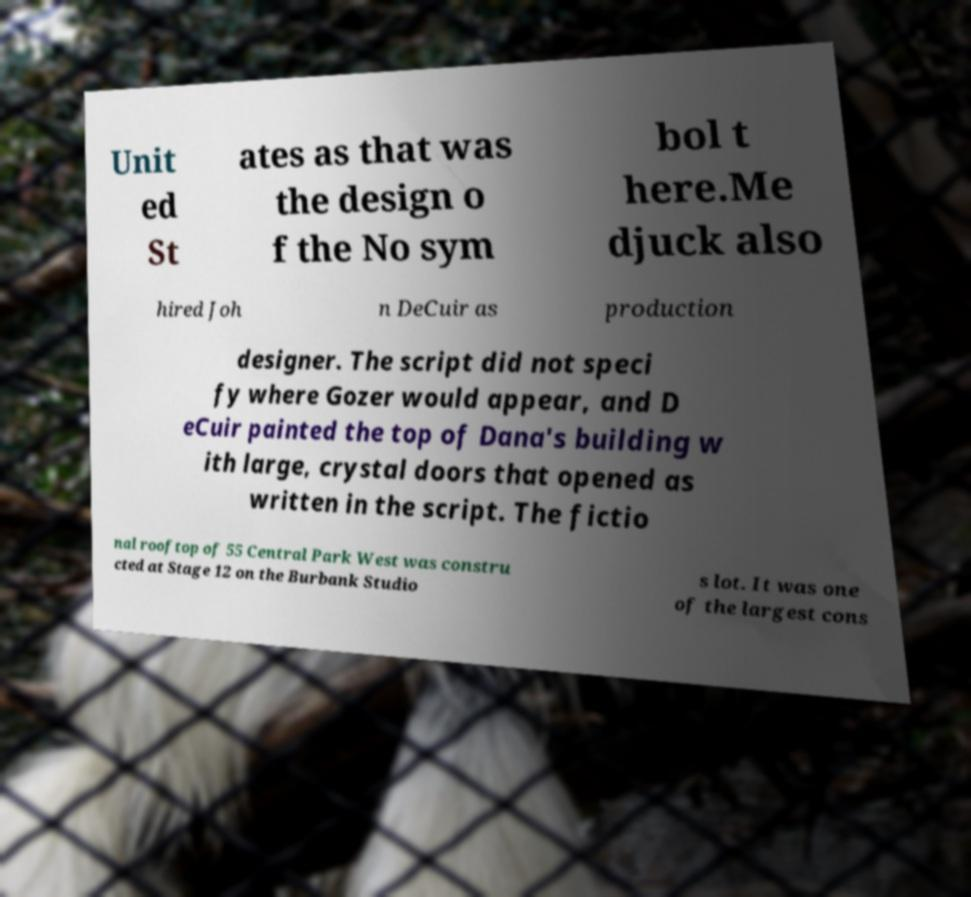Could you assist in decoding the text presented in this image and type it out clearly? Unit ed St ates as that was the design o f the No sym bol t here.Me djuck also hired Joh n DeCuir as production designer. The script did not speci fy where Gozer would appear, and D eCuir painted the top of Dana's building w ith large, crystal doors that opened as written in the script. The fictio nal rooftop of 55 Central Park West was constru cted at Stage 12 on the Burbank Studio s lot. It was one of the largest cons 